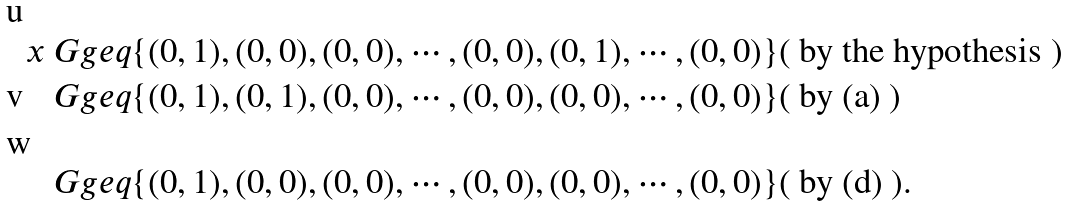<formula> <loc_0><loc_0><loc_500><loc_500>x & \ G g e q \{ ( 0 , 1 ) , ( 0 , 0 ) , ( 0 , 0 ) , \cdots , ( 0 , 0 ) , ( 0 , 1 ) , \cdots , ( 0 , 0 ) \} ( \text { by the hypothesis } ) \\ & \ G g e q \{ ( 0 , 1 ) , ( 0 , 1 ) , ( 0 , 0 ) , \cdots , ( 0 , 0 ) , ( 0 , 0 ) , \cdots , ( 0 , 0 ) \} ( \text { by (a) } ) \\ & \ G g e q \{ ( 0 , 1 ) , ( 0 , 0 ) , ( 0 , 0 ) , \cdots , ( 0 , 0 ) , ( 0 , 0 ) , \cdots , ( 0 , 0 ) \} ( \text { by (d) } ) .</formula> 